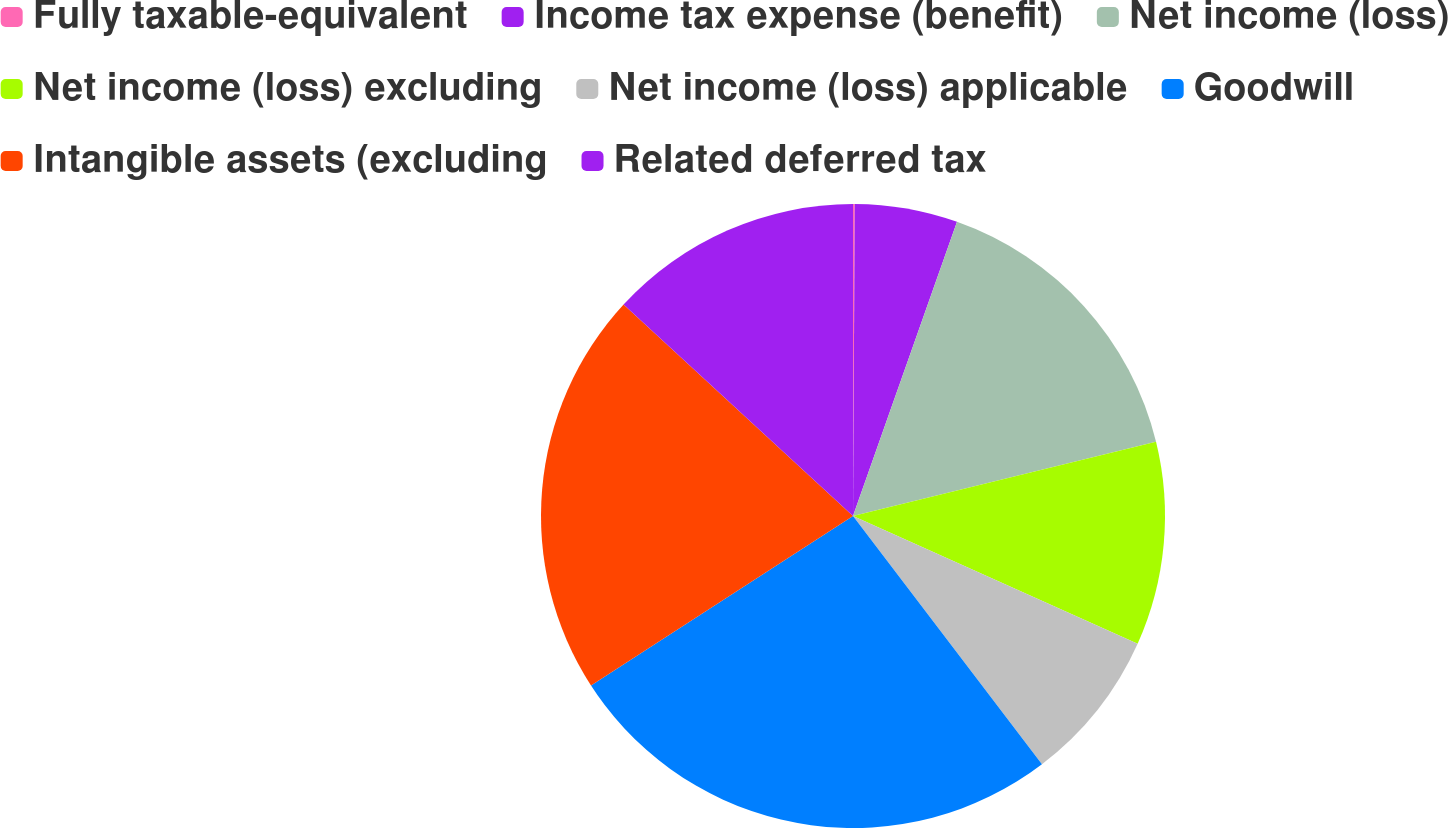Convert chart to OTSL. <chart><loc_0><loc_0><loc_500><loc_500><pie_chart><fcel>Fully taxable-equivalent<fcel>Income tax expense (benefit)<fcel>Net income (loss)<fcel>Net income (loss) excluding<fcel>Net income (loss) applicable<fcel>Goodwill<fcel>Intangible assets (excluding<fcel>Related deferred tax<nl><fcel>0.09%<fcel>5.32%<fcel>15.77%<fcel>10.54%<fcel>7.93%<fcel>26.22%<fcel>20.99%<fcel>13.15%<nl></chart> 